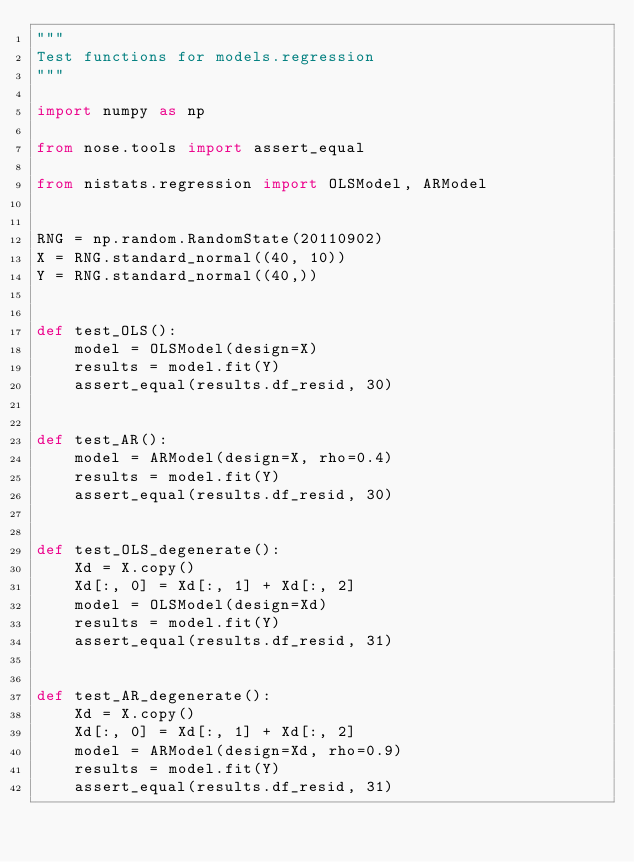Convert code to text. <code><loc_0><loc_0><loc_500><loc_500><_Python_>"""
Test functions for models.regression
"""

import numpy as np

from nose.tools import assert_equal

from nistats.regression import OLSModel, ARModel


RNG = np.random.RandomState(20110902)
X = RNG.standard_normal((40, 10))
Y = RNG.standard_normal((40,))


def test_OLS():
    model = OLSModel(design=X)
    results = model.fit(Y)
    assert_equal(results.df_resid, 30)


def test_AR():
    model = ARModel(design=X, rho=0.4)
    results = model.fit(Y)
    assert_equal(results.df_resid, 30)


def test_OLS_degenerate():
    Xd = X.copy()
    Xd[:, 0] = Xd[:, 1] + Xd[:, 2]
    model = OLSModel(design=Xd)
    results = model.fit(Y)
    assert_equal(results.df_resid, 31)


def test_AR_degenerate():
    Xd = X.copy()
    Xd[:, 0] = Xd[:, 1] + Xd[:, 2]
    model = ARModel(design=Xd, rho=0.9)
    results = model.fit(Y)
    assert_equal(results.df_resid, 31)
</code> 